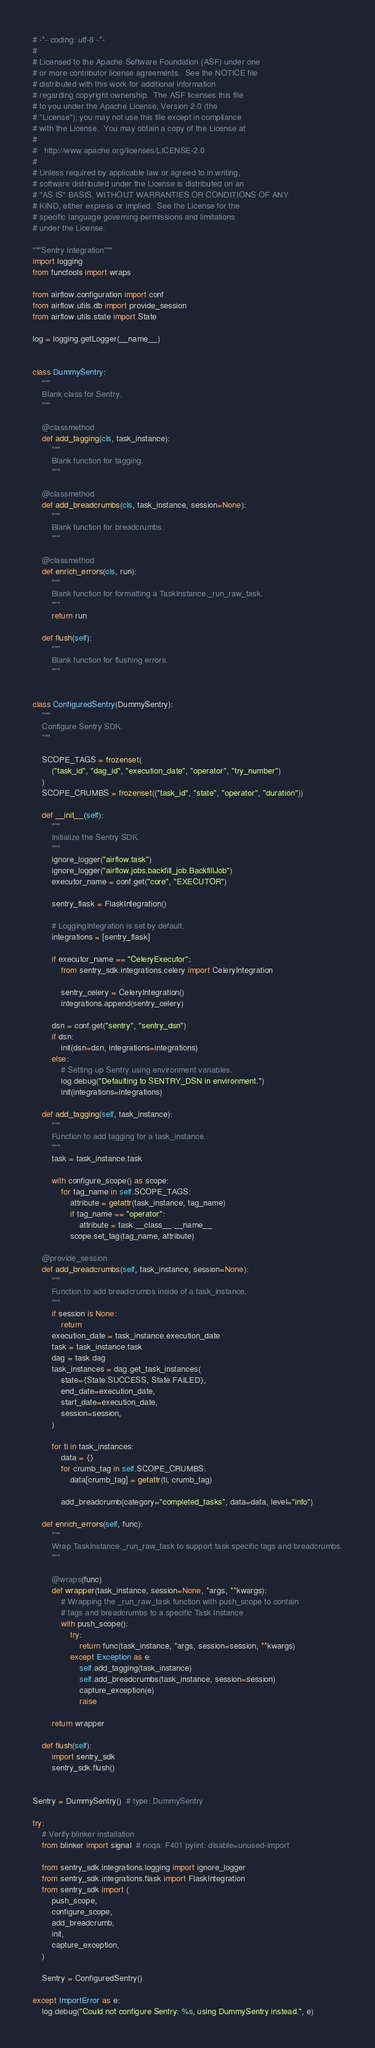<code> <loc_0><loc_0><loc_500><loc_500><_Python_># -*- coding: utf-8 -*-
#
# Licensed to the Apache Software Foundation (ASF) under one
# or more contributor license agreements.  See the NOTICE file
# distributed with this work for additional information
# regarding copyright ownership.  The ASF licenses this file
# to you under the Apache License, Version 2.0 (the
# "License"); you may not use this file except in compliance
# with the License.  You may obtain a copy of the License at
#
#   http://www.apache.org/licenses/LICENSE-2.0
#
# Unless required by applicable law or agreed to in writing,
# software distributed under the License is distributed on an
# "AS IS" BASIS, WITHOUT WARRANTIES OR CONDITIONS OF ANY
# KIND, either express or implied.  See the License for the
# specific language governing permissions and limitations
# under the License.

"""Sentry Integration"""
import logging
from functools import wraps

from airflow.configuration import conf
from airflow.utils.db import provide_session
from airflow.utils.state import State

log = logging.getLogger(__name__)


class DummySentry:
    """
    Blank class for Sentry.
    """

    @classmethod
    def add_tagging(cls, task_instance):
        """
        Blank function for tagging.
        """

    @classmethod
    def add_breadcrumbs(cls, task_instance, session=None):
        """
        Blank function for breadcrumbs.
        """

    @classmethod
    def enrich_errors(cls, run):
        """
        Blank function for formatting a TaskInstance._run_raw_task.
        """
        return run

    def flush(self):
        """
        Blank function for flushing errors.
        """


class ConfiguredSentry(DummySentry):
    """
    Configure Sentry SDK.
    """

    SCOPE_TAGS = frozenset(
        ("task_id", "dag_id", "execution_date", "operator", "try_number")
    )
    SCOPE_CRUMBS = frozenset(("task_id", "state", "operator", "duration"))

    def __init__(self):
        """
        Initialize the Sentry SDK.
        """
        ignore_logger("airflow.task")
        ignore_logger("airflow.jobs.backfill_job.BackfillJob")
        executor_name = conf.get("core", "EXECUTOR")

        sentry_flask = FlaskIntegration()

        # LoggingIntegration is set by default.
        integrations = [sentry_flask]

        if executor_name == "CeleryExecutor":
            from sentry_sdk.integrations.celery import CeleryIntegration

            sentry_celery = CeleryIntegration()
            integrations.append(sentry_celery)

        dsn = conf.get("sentry", "sentry_dsn")
        if dsn:
            init(dsn=dsn, integrations=integrations)
        else:
            # Setting up Sentry using environment variables.
            log.debug("Defaulting to SENTRY_DSN in environment.")
            init(integrations=integrations)

    def add_tagging(self, task_instance):
        """
        Function to add tagging for a task_instance.
        """
        task = task_instance.task

        with configure_scope() as scope:
            for tag_name in self.SCOPE_TAGS:
                attribute = getattr(task_instance, tag_name)
                if tag_name == "operator":
                    attribute = task.__class__.__name__
                scope.set_tag(tag_name, attribute)

    @provide_session
    def add_breadcrumbs(self, task_instance, session=None):
        """
        Function to add breadcrumbs inside of a task_instance.
        """
        if session is None:
            return
        execution_date = task_instance.execution_date
        task = task_instance.task
        dag = task.dag
        task_instances = dag.get_task_instances(
            state={State.SUCCESS, State.FAILED},
            end_date=execution_date,
            start_date=execution_date,
            session=session,
        )

        for ti in task_instances:
            data = {}
            for crumb_tag in self.SCOPE_CRUMBS:
                data[crumb_tag] = getattr(ti, crumb_tag)

            add_breadcrumb(category="completed_tasks", data=data, level="info")

    def enrich_errors(self, func):
        """
        Wrap TaskInstance._run_raw_task to support task specific tags and breadcrumbs.
        """

        @wraps(func)
        def wrapper(task_instance, session=None, *args, **kwargs):
            # Wrapping the _run_raw_task function with push_scope to contain
            # tags and breadcrumbs to a specific Task Instance
            with push_scope():
                try:
                    return func(task_instance, *args, session=session, **kwargs)
                except Exception as e:
                    self.add_tagging(task_instance)
                    self.add_breadcrumbs(task_instance, session=session)
                    capture_exception(e)
                    raise

        return wrapper

    def flush(self):
        import sentry_sdk
        sentry_sdk.flush()


Sentry = DummySentry()  # type: DummySentry

try:
    # Verify blinker installation
    from blinker import signal  # noqa: F401 pylint: disable=unused-import

    from sentry_sdk.integrations.logging import ignore_logger
    from sentry_sdk.integrations.flask import FlaskIntegration
    from sentry_sdk import (
        push_scope,
        configure_scope,
        add_breadcrumb,
        init,
        capture_exception,
    )

    Sentry = ConfiguredSentry()

except ImportError as e:
    log.debug("Could not configure Sentry: %s, using DummySentry instead.", e)
</code> 